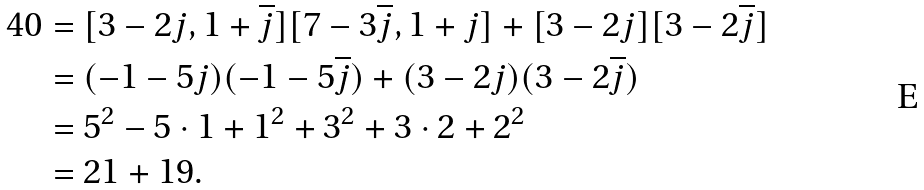<formula> <loc_0><loc_0><loc_500><loc_500>4 0 & = [ 3 - 2 j , 1 + \overline { j } ] [ 7 - 3 \overline { j } , 1 + j ] + [ 3 - 2 j ] [ 3 - 2 \overline { j } ] \\ & = ( - 1 - 5 j ) ( - 1 - 5 \overline { j } ) + ( 3 - 2 j ) ( 3 - 2 \overline { j } ) \\ & = 5 ^ { 2 } - 5 \cdot 1 + 1 ^ { 2 } + 3 ^ { 2 } + 3 \cdot 2 + 2 ^ { 2 } \\ & = 2 1 + 1 9 .</formula> 